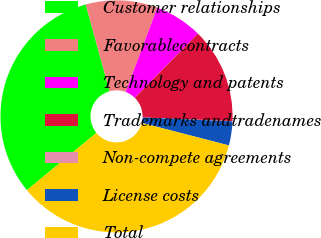<chart> <loc_0><loc_0><loc_500><loc_500><pie_chart><fcel>Customer relationships<fcel>Favorablecontracts<fcel>Technology and patents<fcel>Trademarks andtradenames<fcel>Non-compete agreements<fcel>License costs<fcel>Total<nl><fcel>31.69%<fcel>9.98%<fcel>6.66%<fcel>13.29%<fcel>0.03%<fcel>3.34%<fcel>35.01%<nl></chart> 